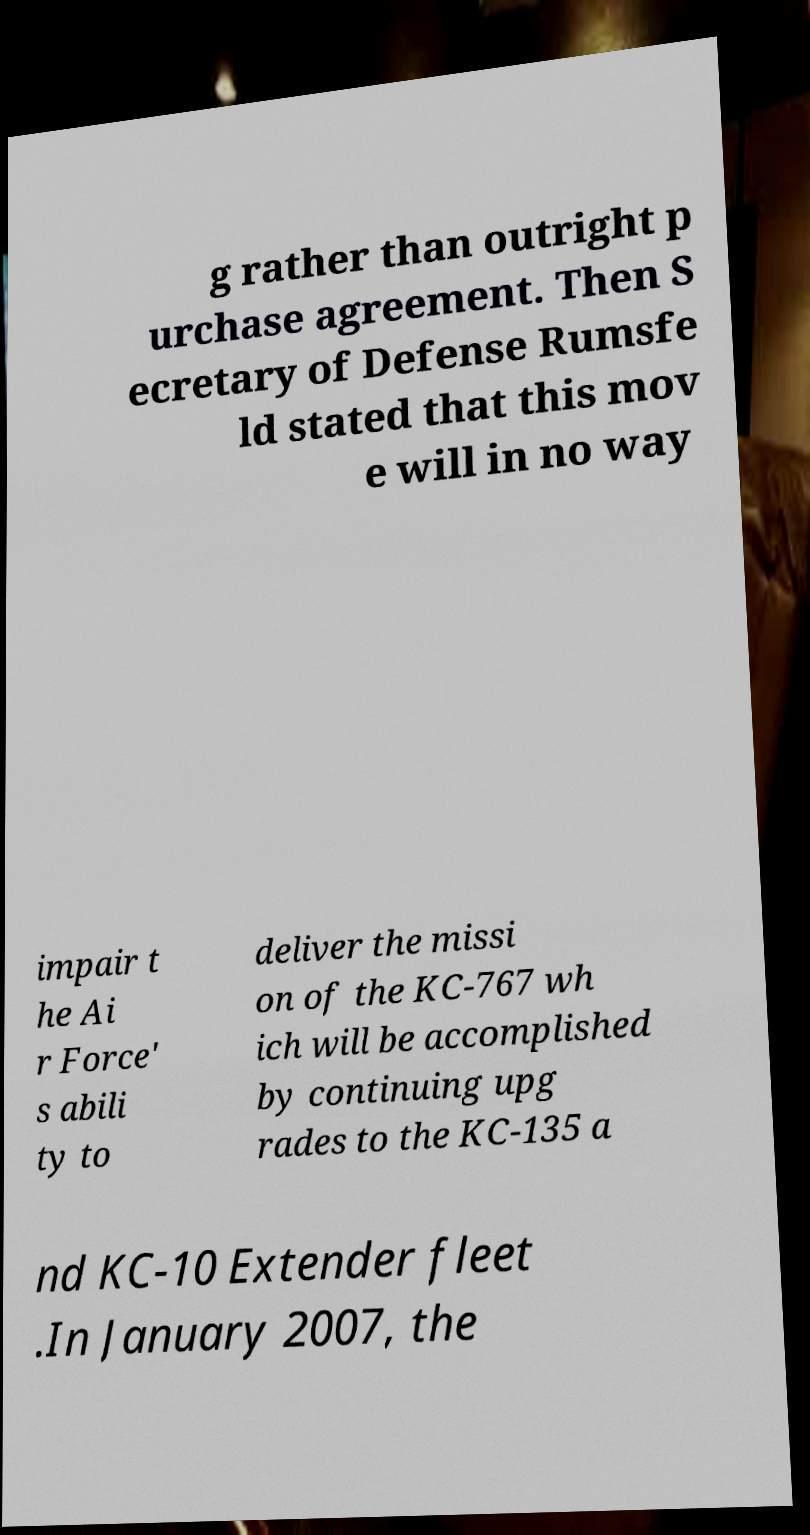Can you read and provide the text displayed in the image?This photo seems to have some interesting text. Can you extract and type it out for me? g rather than outright p urchase agreement. Then S ecretary of Defense Rumsfe ld stated that this mov e will in no way impair t he Ai r Force' s abili ty to deliver the missi on of the KC-767 wh ich will be accomplished by continuing upg rades to the KC-135 a nd KC-10 Extender fleet .In January 2007, the 